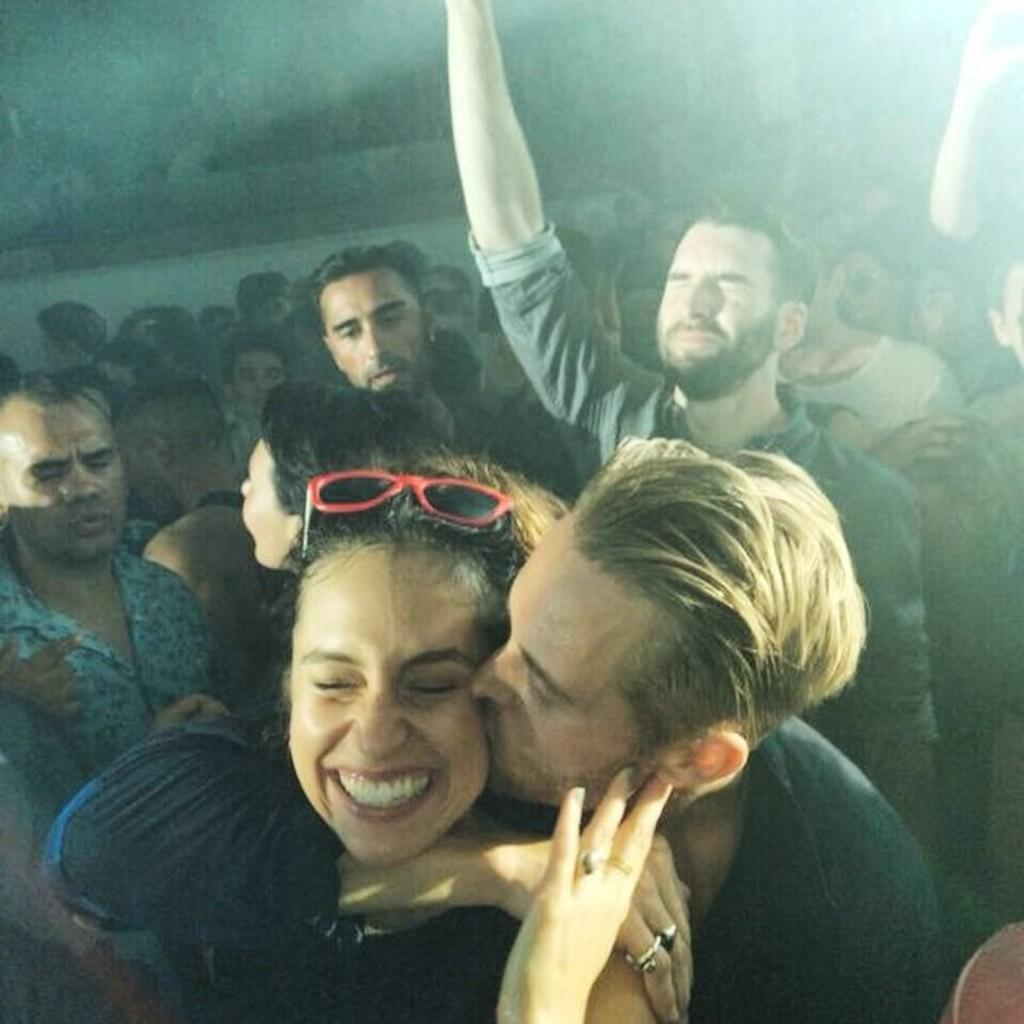How many people are in the image? There are people in the image. What are the people in the image doing? A man is kissing a woman in the image. What can be observed about the background of the image? The background of the image is dark. What type of creature can be seen in the scene? There is no creature present in the image; it features people in a romantic setting. What is the weight of the scene? The concept of weight cannot be applied to a scene or image; it is a physical property of objects. 